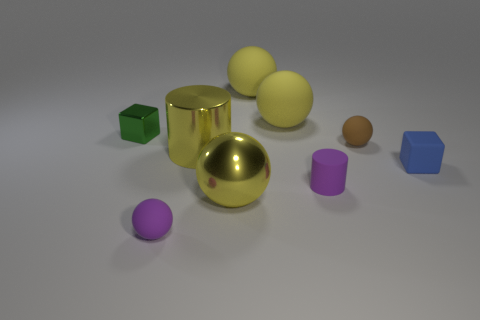Is there a tiny sphere that has the same color as the small cylinder?
Keep it short and to the point. Yes. Do the tiny sphere that is left of the purple rubber cylinder and the small matte cylinder have the same color?
Ensure brevity in your answer.  Yes. How many things are small spheres that are left of the purple cylinder or spheres?
Give a very brief answer. 5. There is a large yellow metal cylinder; are there any large yellow cylinders on the left side of it?
Keep it short and to the point. No. What material is the cylinder that is the same color as the shiny ball?
Keep it short and to the point. Metal. Is the small block that is to the right of the green object made of the same material as the purple cylinder?
Provide a short and direct response. Yes. Are there any yellow spheres in front of the cylinder in front of the block in front of the tiny green cube?
Provide a short and direct response. Yes. What number of cylinders are tiny purple objects or tiny matte objects?
Your answer should be very brief. 1. There is a cylinder that is in front of the blue rubber cube; what is its material?
Make the answer very short. Rubber. The rubber sphere that is the same color as the small cylinder is what size?
Make the answer very short. Small. 